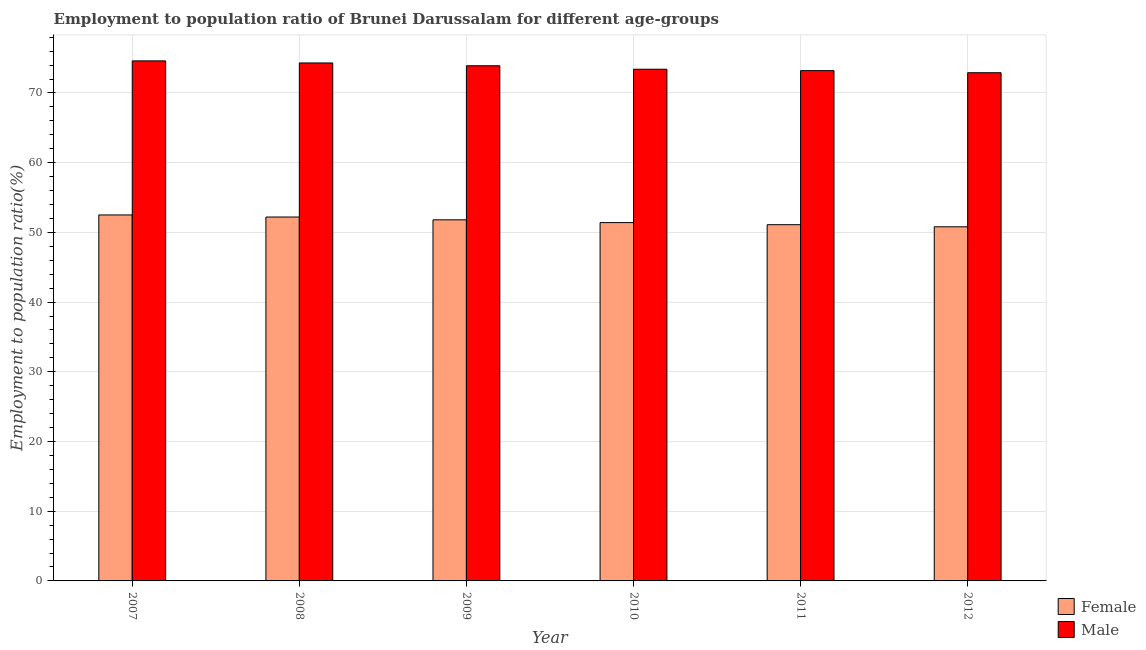How many groups of bars are there?
Your response must be concise. 6. How many bars are there on the 4th tick from the left?
Keep it short and to the point. 2. What is the label of the 3rd group of bars from the left?
Your response must be concise. 2009. In how many cases, is the number of bars for a given year not equal to the number of legend labels?
Keep it short and to the point. 0. What is the employment to population ratio(female) in 2008?
Your response must be concise. 52.2. Across all years, what is the maximum employment to population ratio(female)?
Your response must be concise. 52.5. Across all years, what is the minimum employment to population ratio(female)?
Make the answer very short. 50.8. What is the total employment to population ratio(female) in the graph?
Ensure brevity in your answer.  309.8. What is the difference between the employment to population ratio(male) in 2008 and that in 2009?
Provide a succinct answer. 0.4. What is the difference between the employment to population ratio(male) in 2011 and the employment to population ratio(female) in 2010?
Provide a short and direct response. -0.2. What is the average employment to population ratio(male) per year?
Give a very brief answer. 73.72. In the year 2009, what is the difference between the employment to population ratio(female) and employment to population ratio(male)?
Offer a terse response. 0. In how many years, is the employment to population ratio(female) greater than 12 %?
Ensure brevity in your answer.  6. What is the ratio of the employment to population ratio(male) in 2008 to that in 2010?
Ensure brevity in your answer.  1.01. Is the employment to population ratio(female) in 2007 less than that in 2011?
Your response must be concise. No. Is the difference between the employment to population ratio(male) in 2007 and 2011 greater than the difference between the employment to population ratio(female) in 2007 and 2011?
Make the answer very short. No. What is the difference between the highest and the second highest employment to population ratio(male)?
Your response must be concise. 0.3. What is the difference between the highest and the lowest employment to population ratio(male)?
Ensure brevity in your answer.  1.7. In how many years, is the employment to population ratio(female) greater than the average employment to population ratio(female) taken over all years?
Ensure brevity in your answer.  3. What is the difference between two consecutive major ticks on the Y-axis?
Your answer should be very brief. 10. Are the values on the major ticks of Y-axis written in scientific E-notation?
Make the answer very short. No. Does the graph contain grids?
Give a very brief answer. Yes. How many legend labels are there?
Your response must be concise. 2. How are the legend labels stacked?
Your response must be concise. Vertical. What is the title of the graph?
Make the answer very short. Employment to population ratio of Brunei Darussalam for different age-groups. What is the Employment to population ratio(%) in Female in 2007?
Offer a terse response. 52.5. What is the Employment to population ratio(%) in Male in 2007?
Make the answer very short. 74.6. What is the Employment to population ratio(%) in Female in 2008?
Keep it short and to the point. 52.2. What is the Employment to population ratio(%) of Male in 2008?
Make the answer very short. 74.3. What is the Employment to population ratio(%) of Female in 2009?
Your answer should be very brief. 51.8. What is the Employment to population ratio(%) in Male in 2009?
Offer a terse response. 73.9. What is the Employment to population ratio(%) in Female in 2010?
Make the answer very short. 51.4. What is the Employment to population ratio(%) in Male in 2010?
Make the answer very short. 73.4. What is the Employment to population ratio(%) of Female in 2011?
Make the answer very short. 51.1. What is the Employment to population ratio(%) of Male in 2011?
Make the answer very short. 73.2. What is the Employment to population ratio(%) in Female in 2012?
Your answer should be compact. 50.8. What is the Employment to population ratio(%) in Male in 2012?
Offer a very short reply. 72.9. Across all years, what is the maximum Employment to population ratio(%) in Female?
Your answer should be compact. 52.5. Across all years, what is the maximum Employment to population ratio(%) of Male?
Your answer should be compact. 74.6. Across all years, what is the minimum Employment to population ratio(%) in Female?
Your response must be concise. 50.8. Across all years, what is the minimum Employment to population ratio(%) in Male?
Your answer should be very brief. 72.9. What is the total Employment to population ratio(%) of Female in the graph?
Give a very brief answer. 309.8. What is the total Employment to population ratio(%) of Male in the graph?
Your answer should be compact. 442.3. What is the difference between the Employment to population ratio(%) of Female in 2007 and that in 2009?
Keep it short and to the point. 0.7. What is the difference between the Employment to population ratio(%) in Male in 2007 and that in 2009?
Offer a terse response. 0.7. What is the difference between the Employment to population ratio(%) of Male in 2007 and that in 2010?
Offer a terse response. 1.2. What is the difference between the Employment to population ratio(%) of Female in 2007 and that in 2011?
Offer a terse response. 1.4. What is the difference between the Employment to population ratio(%) in Male in 2007 and that in 2011?
Offer a very short reply. 1.4. What is the difference between the Employment to population ratio(%) in Female in 2007 and that in 2012?
Your response must be concise. 1.7. What is the difference between the Employment to population ratio(%) of Female in 2008 and that in 2009?
Ensure brevity in your answer.  0.4. What is the difference between the Employment to population ratio(%) in Male in 2008 and that in 2011?
Give a very brief answer. 1.1. What is the difference between the Employment to population ratio(%) in Female in 2008 and that in 2012?
Provide a succinct answer. 1.4. What is the difference between the Employment to population ratio(%) in Male in 2009 and that in 2010?
Offer a very short reply. 0.5. What is the difference between the Employment to population ratio(%) in Female in 2009 and that in 2011?
Provide a succinct answer. 0.7. What is the difference between the Employment to population ratio(%) of Male in 2009 and that in 2011?
Make the answer very short. 0.7. What is the difference between the Employment to population ratio(%) in Male in 2010 and that in 2011?
Offer a terse response. 0.2. What is the difference between the Employment to population ratio(%) of Female in 2010 and that in 2012?
Ensure brevity in your answer.  0.6. What is the difference between the Employment to population ratio(%) in Male in 2010 and that in 2012?
Provide a succinct answer. 0.5. What is the difference between the Employment to population ratio(%) in Female in 2011 and that in 2012?
Your response must be concise. 0.3. What is the difference between the Employment to population ratio(%) in Female in 2007 and the Employment to population ratio(%) in Male in 2008?
Keep it short and to the point. -21.8. What is the difference between the Employment to population ratio(%) in Female in 2007 and the Employment to population ratio(%) in Male in 2009?
Your answer should be very brief. -21.4. What is the difference between the Employment to population ratio(%) of Female in 2007 and the Employment to population ratio(%) of Male in 2010?
Offer a terse response. -20.9. What is the difference between the Employment to population ratio(%) of Female in 2007 and the Employment to population ratio(%) of Male in 2011?
Make the answer very short. -20.7. What is the difference between the Employment to population ratio(%) in Female in 2007 and the Employment to population ratio(%) in Male in 2012?
Provide a succinct answer. -20.4. What is the difference between the Employment to population ratio(%) of Female in 2008 and the Employment to population ratio(%) of Male in 2009?
Your response must be concise. -21.7. What is the difference between the Employment to population ratio(%) of Female in 2008 and the Employment to population ratio(%) of Male in 2010?
Your response must be concise. -21.2. What is the difference between the Employment to population ratio(%) of Female in 2008 and the Employment to population ratio(%) of Male in 2011?
Your answer should be compact. -21. What is the difference between the Employment to population ratio(%) of Female in 2008 and the Employment to population ratio(%) of Male in 2012?
Your answer should be compact. -20.7. What is the difference between the Employment to population ratio(%) in Female in 2009 and the Employment to population ratio(%) in Male in 2010?
Your answer should be compact. -21.6. What is the difference between the Employment to population ratio(%) of Female in 2009 and the Employment to population ratio(%) of Male in 2011?
Keep it short and to the point. -21.4. What is the difference between the Employment to population ratio(%) in Female in 2009 and the Employment to population ratio(%) in Male in 2012?
Provide a short and direct response. -21.1. What is the difference between the Employment to population ratio(%) of Female in 2010 and the Employment to population ratio(%) of Male in 2011?
Make the answer very short. -21.8. What is the difference between the Employment to population ratio(%) in Female in 2010 and the Employment to population ratio(%) in Male in 2012?
Give a very brief answer. -21.5. What is the difference between the Employment to population ratio(%) of Female in 2011 and the Employment to population ratio(%) of Male in 2012?
Your response must be concise. -21.8. What is the average Employment to population ratio(%) in Female per year?
Your answer should be compact. 51.63. What is the average Employment to population ratio(%) of Male per year?
Your answer should be compact. 73.72. In the year 2007, what is the difference between the Employment to population ratio(%) of Female and Employment to population ratio(%) of Male?
Your answer should be very brief. -22.1. In the year 2008, what is the difference between the Employment to population ratio(%) in Female and Employment to population ratio(%) in Male?
Provide a short and direct response. -22.1. In the year 2009, what is the difference between the Employment to population ratio(%) of Female and Employment to population ratio(%) of Male?
Your answer should be very brief. -22.1. In the year 2010, what is the difference between the Employment to population ratio(%) of Female and Employment to population ratio(%) of Male?
Give a very brief answer. -22. In the year 2011, what is the difference between the Employment to population ratio(%) of Female and Employment to population ratio(%) of Male?
Your answer should be compact. -22.1. In the year 2012, what is the difference between the Employment to population ratio(%) of Female and Employment to population ratio(%) of Male?
Make the answer very short. -22.1. What is the ratio of the Employment to population ratio(%) of Female in 2007 to that in 2008?
Offer a very short reply. 1.01. What is the ratio of the Employment to population ratio(%) in Male in 2007 to that in 2008?
Your answer should be very brief. 1. What is the ratio of the Employment to population ratio(%) of Female in 2007 to that in 2009?
Offer a terse response. 1.01. What is the ratio of the Employment to population ratio(%) of Male in 2007 to that in 2009?
Your answer should be compact. 1.01. What is the ratio of the Employment to population ratio(%) in Female in 2007 to that in 2010?
Keep it short and to the point. 1.02. What is the ratio of the Employment to population ratio(%) of Male in 2007 to that in 2010?
Ensure brevity in your answer.  1.02. What is the ratio of the Employment to population ratio(%) in Female in 2007 to that in 2011?
Provide a short and direct response. 1.03. What is the ratio of the Employment to population ratio(%) of Male in 2007 to that in 2011?
Offer a very short reply. 1.02. What is the ratio of the Employment to population ratio(%) of Female in 2007 to that in 2012?
Ensure brevity in your answer.  1.03. What is the ratio of the Employment to population ratio(%) in Male in 2007 to that in 2012?
Give a very brief answer. 1.02. What is the ratio of the Employment to population ratio(%) in Female in 2008 to that in 2009?
Provide a short and direct response. 1.01. What is the ratio of the Employment to population ratio(%) of Male in 2008 to that in 2009?
Ensure brevity in your answer.  1.01. What is the ratio of the Employment to population ratio(%) in Female in 2008 to that in 2010?
Make the answer very short. 1.02. What is the ratio of the Employment to population ratio(%) in Male in 2008 to that in 2010?
Provide a short and direct response. 1.01. What is the ratio of the Employment to population ratio(%) in Female in 2008 to that in 2011?
Keep it short and to the point. 1.02. What is the ratio of the Employment to population ratio(%) in Female in 2008 to that in 2012?
Your response must be concise. 1.03. What is the ratio of the Employment to population ratio(%) of Male in 2008 to that in 2012?
Your answer should be compact. 1.02. What is the ratio of the Employment to population ratio(%) of Male in 2009 to that in 2010?
Provide a short and direct response. 1.01. What is the ratio of the Employment to population ratio(%) of Female in 2009 to that in 2011?
Offer a terse response. 1.01. What is the ratio of the Employment to population ratio(%) of Male in 2009 to that in 2011?
Your response must be concise. 1.01. What is the ratio of the Employment to population ratio(%) in Female in 2009 to that in 2012?
Make the answer very short. 1.02. What is the ratio of the Employment to population ratio(%) of Male in 2009 to that in 2012?
Give a very brief answer. 1.01. What is the ratio of the Employment to population ratio(%) of Female in 2010 to that in 2011?
Offer a terse response. 1.01. What is the ratio of the Employment to population ratio(%) in Female in 2010 to that in 2012?
Ensure brevity in your answer.  1.01. What is the ratio of the Employment to population ratio(%) of Male in 2010 to that in 2012?
Provide a succinct answer. 1.01. What is the ratio of the Employment to population ratio(%) in Female in 2011 to that in 2012?
Ensure brevity in your answer.  1.01. What is the ratio of the Employment to population ratio(%) in Male in 2011 to that in 2012?
Keep it short and to the point. 1. What is the difference between the highest and the second highest Employment to population ratio(%) in Female?
Offer a terse response. 0.3. What is the difference between the highest and the second highest Employment to population ratio(%) in Male?
Your answer should be very brief. 0.3. What is the difference between the highest and the lowest Employment to population ratio(%) in Male?
Provide a short and direct response. 1.7. 